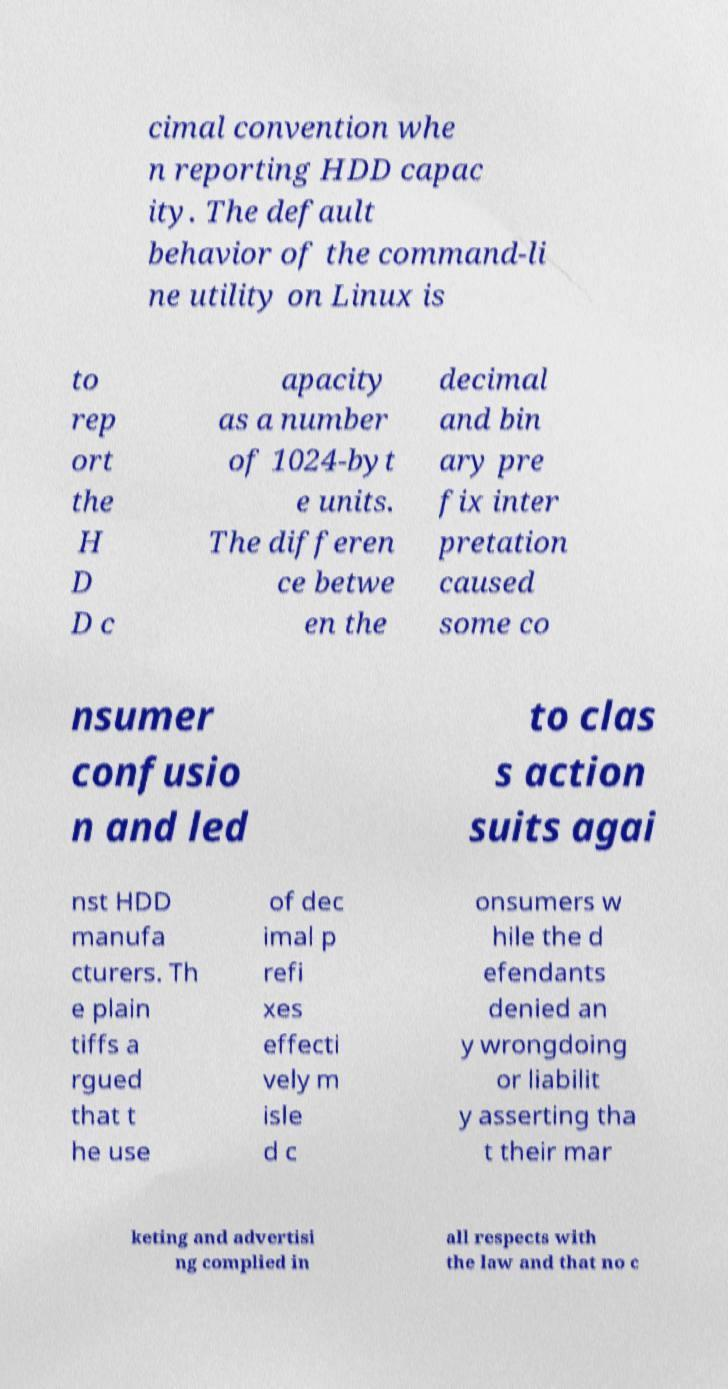There's text embedded in this image that I need extracted. Can you transcribe it verbatim? cimal convention whe n reporting HDD capac ity. The default behavior of the command-li ne utility on Linux is to rep ort the H D D c apacity as a number of 1024-byt e units. The differen ce betwe en the decimal and bin ary pre fix inter pretation caused some co nsumer confusio n and led to clas s action suits agai nst HDD manufa cturers. Th e plain tiffs a rgued that t he use of dec imal p refi xes effecti vely m isle d c onsumers w hile the d efendants denied an y wrongdoing or liabilit y asserting tha t their mar keting and advertisi ng complied in all respects with the law and that no c 